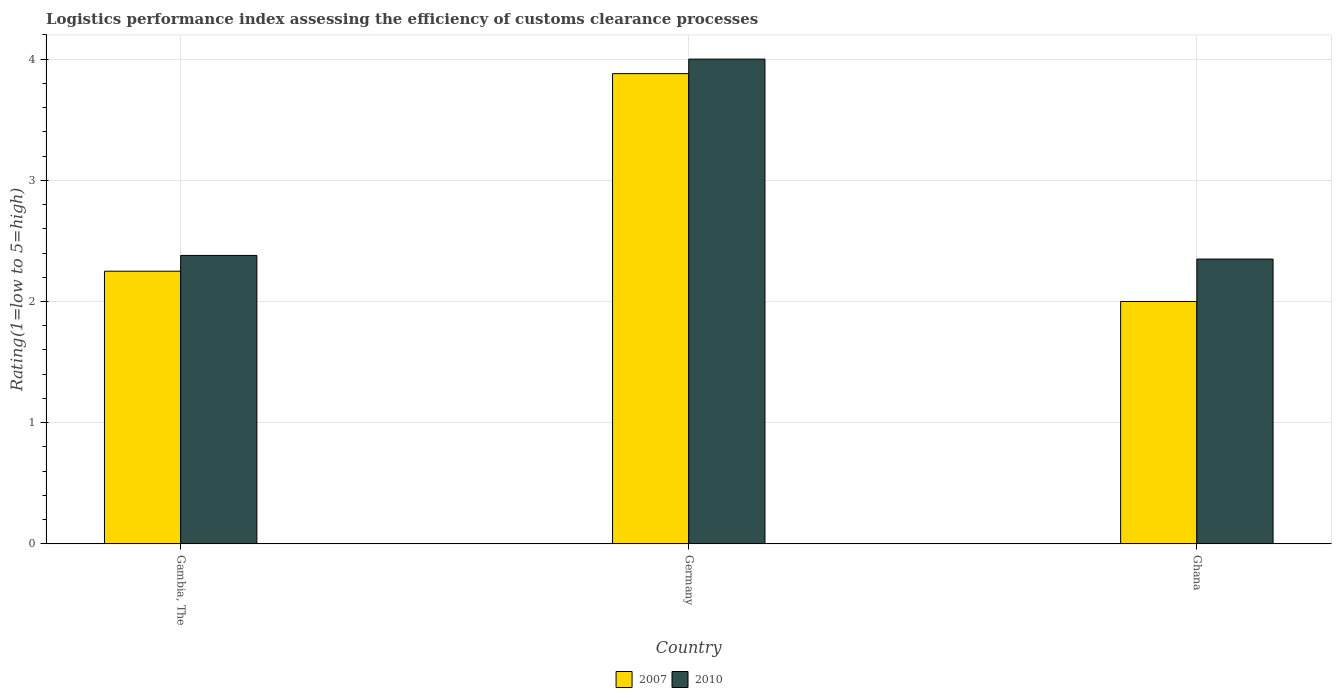How many different coloured bars are there?
Make the answer very short. 2. How many groups of bars are there?
Your answer should be compact. 3. Are the number of bars on each tick of the X-axis equal?
Offer a terse response. Yes. What is the Logistic performance index in 2007 in Gambia, The?
Your answer should be very brief. 2.25. Across all countries, what is the maximum Logistic performance index in 2007?
Provide a short and direct response. 3.88. Across all countries, what is the minimum Logistic performance index in 2007?
Ensure brevity in your answer.  2. In which country was the Logistic performance index in 2010 maximum?
Your response must be concise. Germany. In which country was the Logistic performance index in 2007 minimum?
Provide a succinct answer. Ghana. What is the total Logistic performance index in 2007 in the graph?
Keep it short and to the point. 8.13. What is the difference between the Logistic performance index in 2007 in Ghana and the Logistic performance index in 2010 in Gambia, The?
Offer a terse response. -0.38. What is the average Logistic performance index in 2010 per country?
Your answer should be compact. 2.91. What is the difference between the Logistic performance index of/in 2007 and Logistic performance index of/in 2010 in Ghana?
Provide a short and direct response. -0.35. In how many countries, is the Logistic performance index in 2010 greater than 3?
Provide a short and direct response. 1. What is the ratio of the Logistic performance index in 2007 in Gambia, The to that in Ghana?
Offer a terse response. 1.12. Is the Logistic performance index in 2007 in Gambia, The less than that in Ghana?
Your response must be concise. No. What is the difference between the highest and the lowest Logistic performance index in 2010?
Provide a succinct answer. 1.65. What does the 2nd bar from the right in Germany represents?
Your answer should be very brief. 2007. How many bars are there?
Provide a short and direct response. 6. Are all the bars in the graph horizontal?
Your answer should be very brief. No. What is the difference between two consecutive major ticks on the Y-axis?
Provide a short and direct response. 1. Does the graph contain any zero values?
Ensure brevity in your answer.  No. Does the graph contain grids?
Keep it short and to the point. Yes. How are the legend labels stacked?
Ensure brevity in your answer.  Horizontal. What is the title of the graph?
Provide a short and direct response. Logistics performance index assessing the efficiency of customs clearance processes. Does "2005" appear as one of the legend labels in the graph?
Offer a very short reply. No. What is the label or title of the Y-axis?
Offer a very short reply. Rating(1=low to 5=high). What is the Rating(1=low to 5=high) of 2007 in Gambia, The?
Give a very brief answer. 2.25. What is the Rating(1=low to 5=high) in 2010 in Gambia, The?
Your answer should be compact. 2.38. What is the Rating(1=low to 5=high) in 2007 in Germany?
Provide a succinct answer. 3.88. What is the Rating(1=low to 5=high) in 2010 in Ghana?
Make the answer very short. 2.35. Across all countries, what is the maximum Rating(1=low to 5=high) in 2007?
Provide a short and direct response. 3.88. Across all countries, what is the maximum Rating(1=low to 5=high) in 2010?
Your answer should be very brief. 4. Across all countries, what is the minimum Rating(1=low to 5=high) of 2010?
Offer a very short reply. 2.35. What is the total Rating(1=low to 5=high) in 2007 in the graph?
Ensure brevity in your answer.  8.13. What is the total Rating(1=low to 5=high) of 2010 in the graph?
Keep it short and to the point. 8.73. What is the difference between the Rating(1=low to 5=high) in 2007 in Gambia, The and that in Germany?
Keep it short and to the point. -1.63. What is the difference between the Rating(1=low to 5=high) of 2010 in Gambia, The and that in Germany?
Give a very brief answer. -1.62. What is the difference between the Rating(1=low to 5=high) of 2007 in Gambia, The and that in Ghana?
Your answer should be very brief. 0.25. What is the difference between the Rating(1=low to 5=high) of 2010 in Gambia, The and that in Ghana?
Give a very brief answer. 0.03. What is the difference between the Rating(1=low to 5=high) of 2007 in Germany and that in Ghana?
Provide a succinct answer. 1.88. What is the difference between the Rating(1=low to 5=high) in 2010 in Germany and that in Ghana?
Give a very brief answer. 1.65. What is the difference between the Rating(1=low to 5=high) of 2007 in Gambia, The and the Rating(1=low to 5=high) of 2010 in Germany?
Make the answer very short. -1.75. What is the difference between the Rating(1=low to 5=high) of 2007 in Germany and the Rating(1=low to 5=high) of 2010 in Ghana?
Keep it short and to the point. 1.53. What is the average Rating(1=low to 5=high) of 2007 per country?
Offer a terse response. 2.71. What is the average Rating(1=low to 5=high) of 2010 per country?
Ensure brevity in your answer.  2.91. What is the difference between the Rating(1=low to 5=high) in 2007 and Rating(1=low to 5=high) in 2010 in Gambia, The?
Ensure brevity in your answer.  -0.13. What is the difference between the Rating(1=low to 5=high) in 2007 and Rating(1=low to 5=high) in 2010 in Germany?
Offer a very short reply. -0.12. What is the difference between the Rating(1=low to 5=high) in 2007 and Rating(1=low to 5=high) in 2010 in Ghana?
Keep it short and to the point. -0.35. What is the ratio of the Rating(1=low to 5=high) of 2007 in Gambia, The to that in Germany?
Ensure brevity in your answer.  0.58. What is the ratio of the Rating(1=low to 5=high) in 2010 in Gambia, The to that in Germany?
Your answer should be compact. 0.59. What is the ratio of the Rating(1=low to 5=high) of 2010 in Gambia, The to that in Ghana?
Ensure brevity in your answer.  1.01. What is the ratio of the Rating(1=low to 5=high) in 2007 in Germany to that in Ghana?
Provide a short and direct response. 1.94. What is the ratio of the Rating(1=low to 5=high) in 2010 in Germany to that in Ghana?
Your response must be concise. 1.7. What is the difference between the highest and the second highest Rating(1=low to 5=high) in 2007?
Provide a succinct answer. 1.63. What is the difference between the highest and the second highest Rating(1=low to 5=high) of 2010?
Offer a very short reply. 1.62. What is the difference between the highest and the lowest Rating(1=low to 5=high) of 2007?
Your answer should be very brief. 1.88. What is the difference between the highest and the lowest Rating(1=low to 5=high) in 2010?
Give a very brief answer. 1.65. 